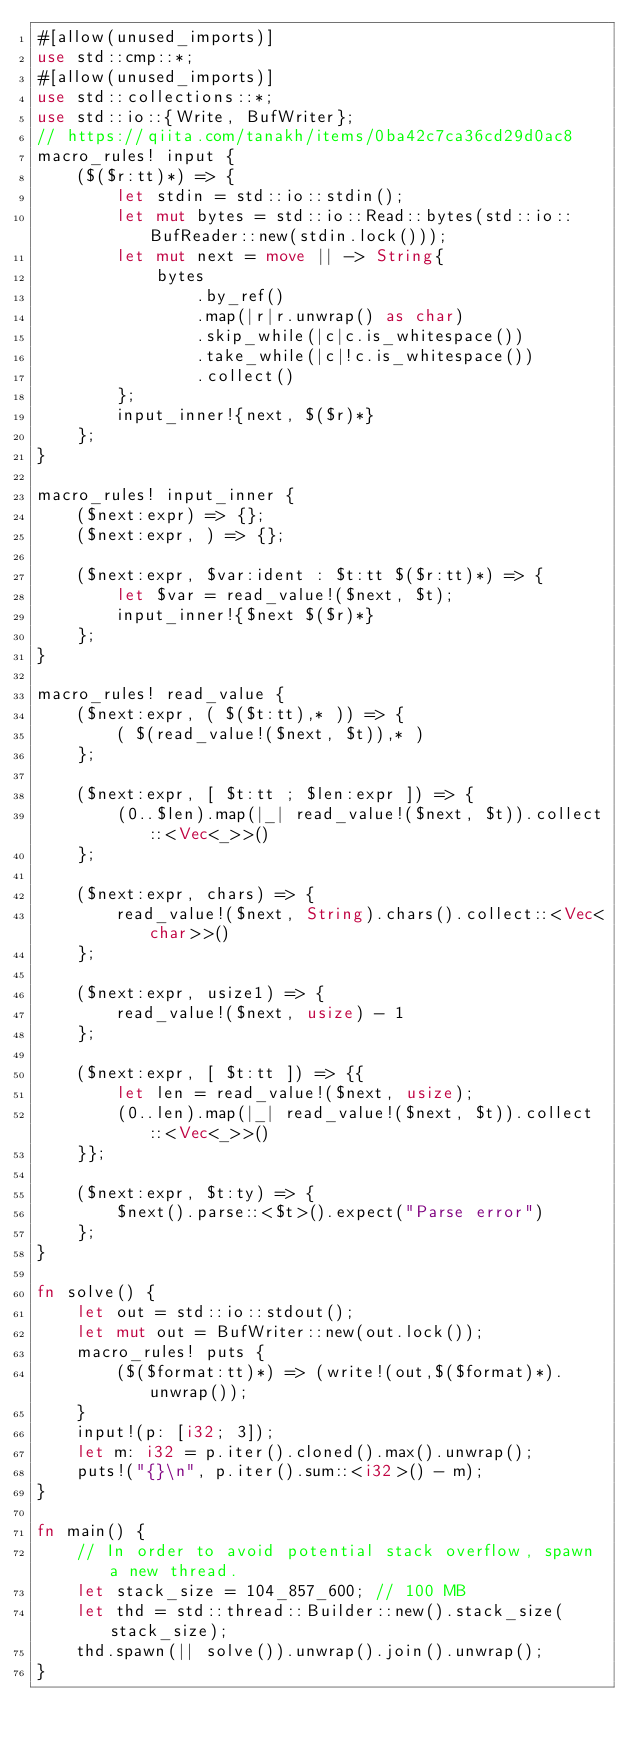<code> <loc_0><loc_0><loc_500><loc_500><_Rust_>#[allow(unused_imports)]
use std::cmp::*;
#[allow(unused_imports)]
use std::collections::*;
use std::io::{Write, BufWriter};
// https://qiita.com/tanakh/items/0ba42c7ca36cd29d0ac8
macro_rules! input {
    ($($r:tt)*) => {
        let stdin = std::io::stdin();
        let mut bytes = std::io::Read::bytes(std::io::BufReader::new(stdin.lock()));
        let mut next = move || -> String{
            bytes
                .by_ref()
                .map(|r|r.unwrap() as char)
                .skip_while(|c|c.is_whitespace())
                .take_while(|c|!c.is_whitespace())
                .collect()
        };
        input_inner!{next, $($r)*}
    };
}

macro_rules! input_inner {
    ($next:expr) => {};
    ($next:expr, ) => {};

    ($next:expr, $var:ident : $t:tt $($r:tt)*) => {
        let $var = read_value!($next, $t);
        input_inner!{$next $($r)*}
    };
}

macro_rules! read_value {
    ($next:expr, ( $($t:tt),* )) => {
        ( $(read_value!($next, $t)),* )
    };

    ($next:expr, [ $t:tt ; $len:expr ]) => {
        (0..$len).map(|_| read_value!($next, $t)).collect::<Vec<_>>()
    };

    ($next:expr, chars) => {
        read_value!($next, String).chars().collect::<Vec<char>>()
    };

    ($next:expr, usize1) => {
        read_value!($next, usize) - 1
    };

    ($next:expr, [ $t:tt ]) => {{
        let len = read_value!($next, usize);
        (0..len).map(|_| read_value!($next, $t)).collect::<Vec<_>>()
    }};

    ($next:expr, $t:ty) => {
        $next().parse::<$t>().expect("Parse error")
    };
}

fn solve() {
    let out = std::io::stdout();
    let mut out = BufWriter::new(out.lock());
    macro_rules! puts {
        ($($format:tt)*) => (write!(out,$($format)*).unwrap());
    }
    input!(p: [i32; 3]);
    let m: i32 = p.iter().cloned().max().unwrap();
    puts!("{}\n", p.iter().sum::<i32>() - m);
}

fn main() {
    // In order to avoid potential stack overflow, spawn a new thread.
    let stack_size = 104_857_600; // 100 MB
    let thd = std::thread::Builder::new().stack_size(stack_size);
    thd.spawn(|| solve()).unwrap().join().unwrap();
}
</code> 